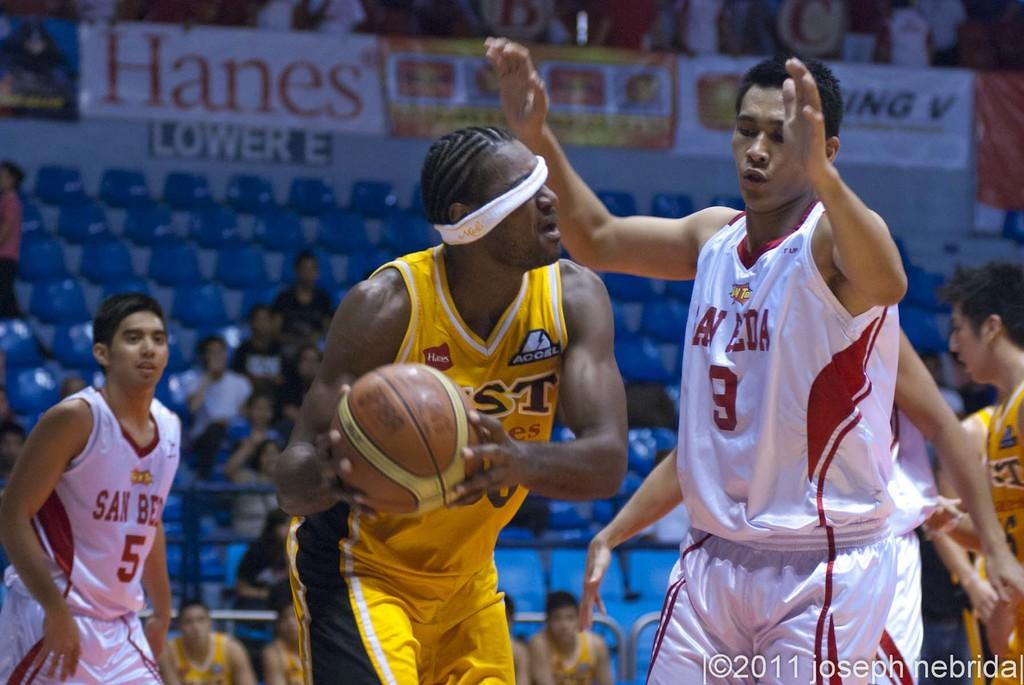Provide a one-sentence caption for the provided image. A black blindfolded man in a yellow jersey with a Hanes sponsor holds basketball. 